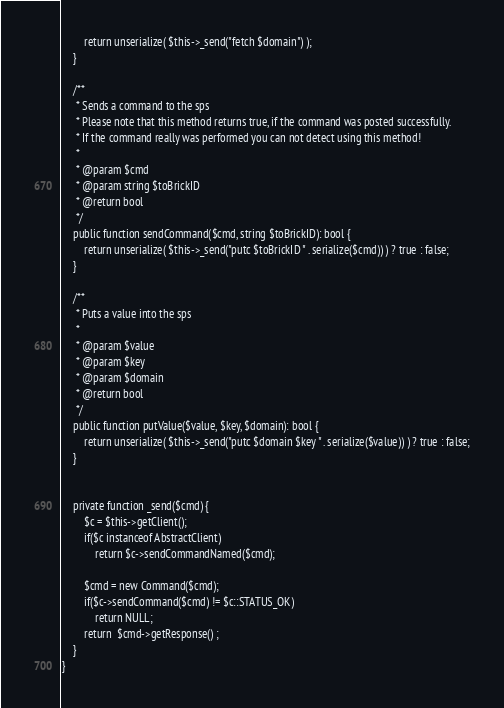<code> <loc_0><loc_0><loc_500><loc_500><_PHP_>        return unserialize( $this->_send("fetch $domain") );
    }

    /**
     * Sends a command to the sps
     * Please note that this method returns true, if the command was posted successfully.
     * If the command really was performed you can not detect using this method!
     *
     * @param $cmd
     * @param string $toBrickID
     * @return bool
     */
    public function sendCommand($cmd, string $toBrickID): bool {
        return unserialize( $this->_send("putc $toBrickID " . serialize($cmd)) ) ? true : false;
    }

    /**
     * Puts a value into the sps
     *
     * @param $value
     * @param $key
     * @param $domain
     * @return bool
     */
    public function putValue($value, $key, $domain): bool {
        return unserialize( $this->_send("putc $domain $key " . serialize($value)) ) ? true : false;
    }


    private function _send($cmd) {
        $c = $this->getClient();
        if($c instanceof AbstractClient)
            return $c->sendCommandNamed($cmd);

        $cmd = new Command($cmd);
        if($c->sendCommand($cmd) != $c::STATUS_OK)
            return NULL;
        return  $cmd->getResponse() ;
    }
}</code> 